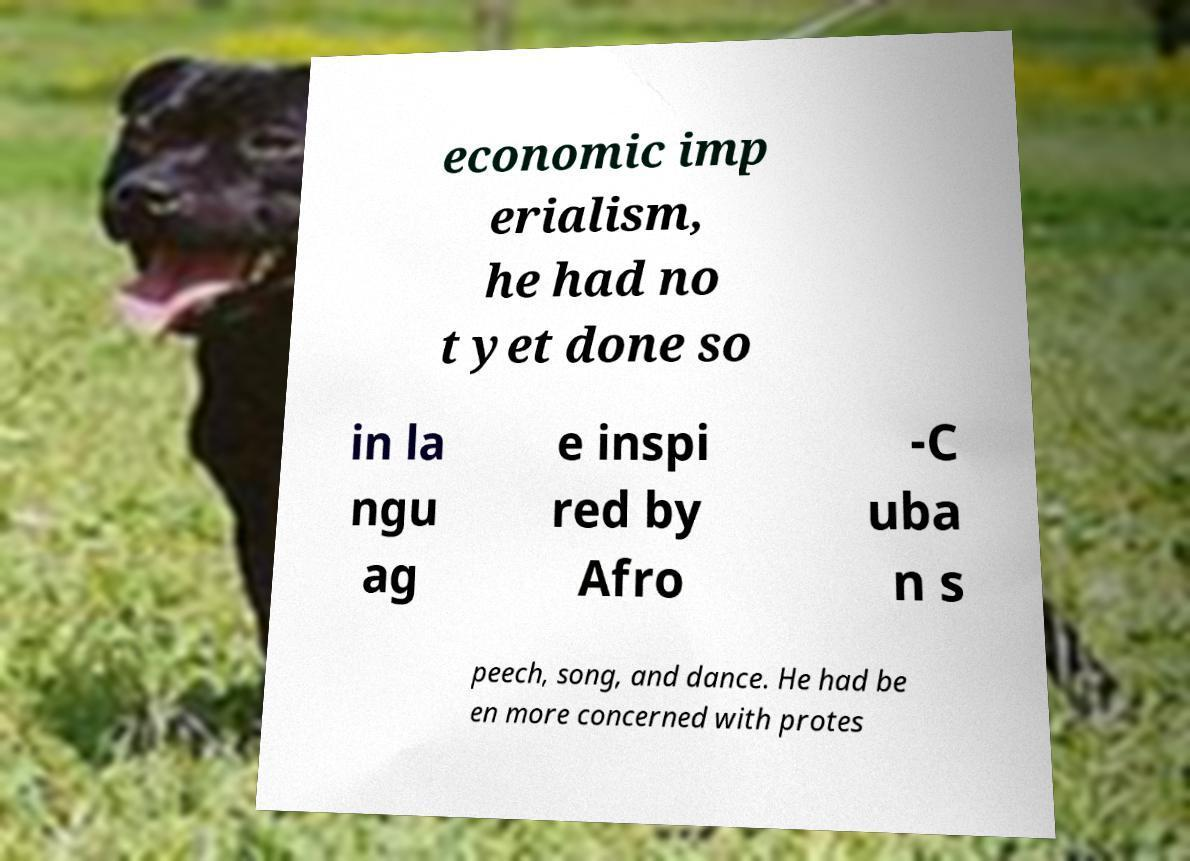There's text embedded in this image that I need extracted. Can you transcribe it verbatim? economic imp erialism, he had no t yet done so in la ngu ag e inspi red by Afro -C uba n s peech, song, and dance. He had be en more concerned with protes 